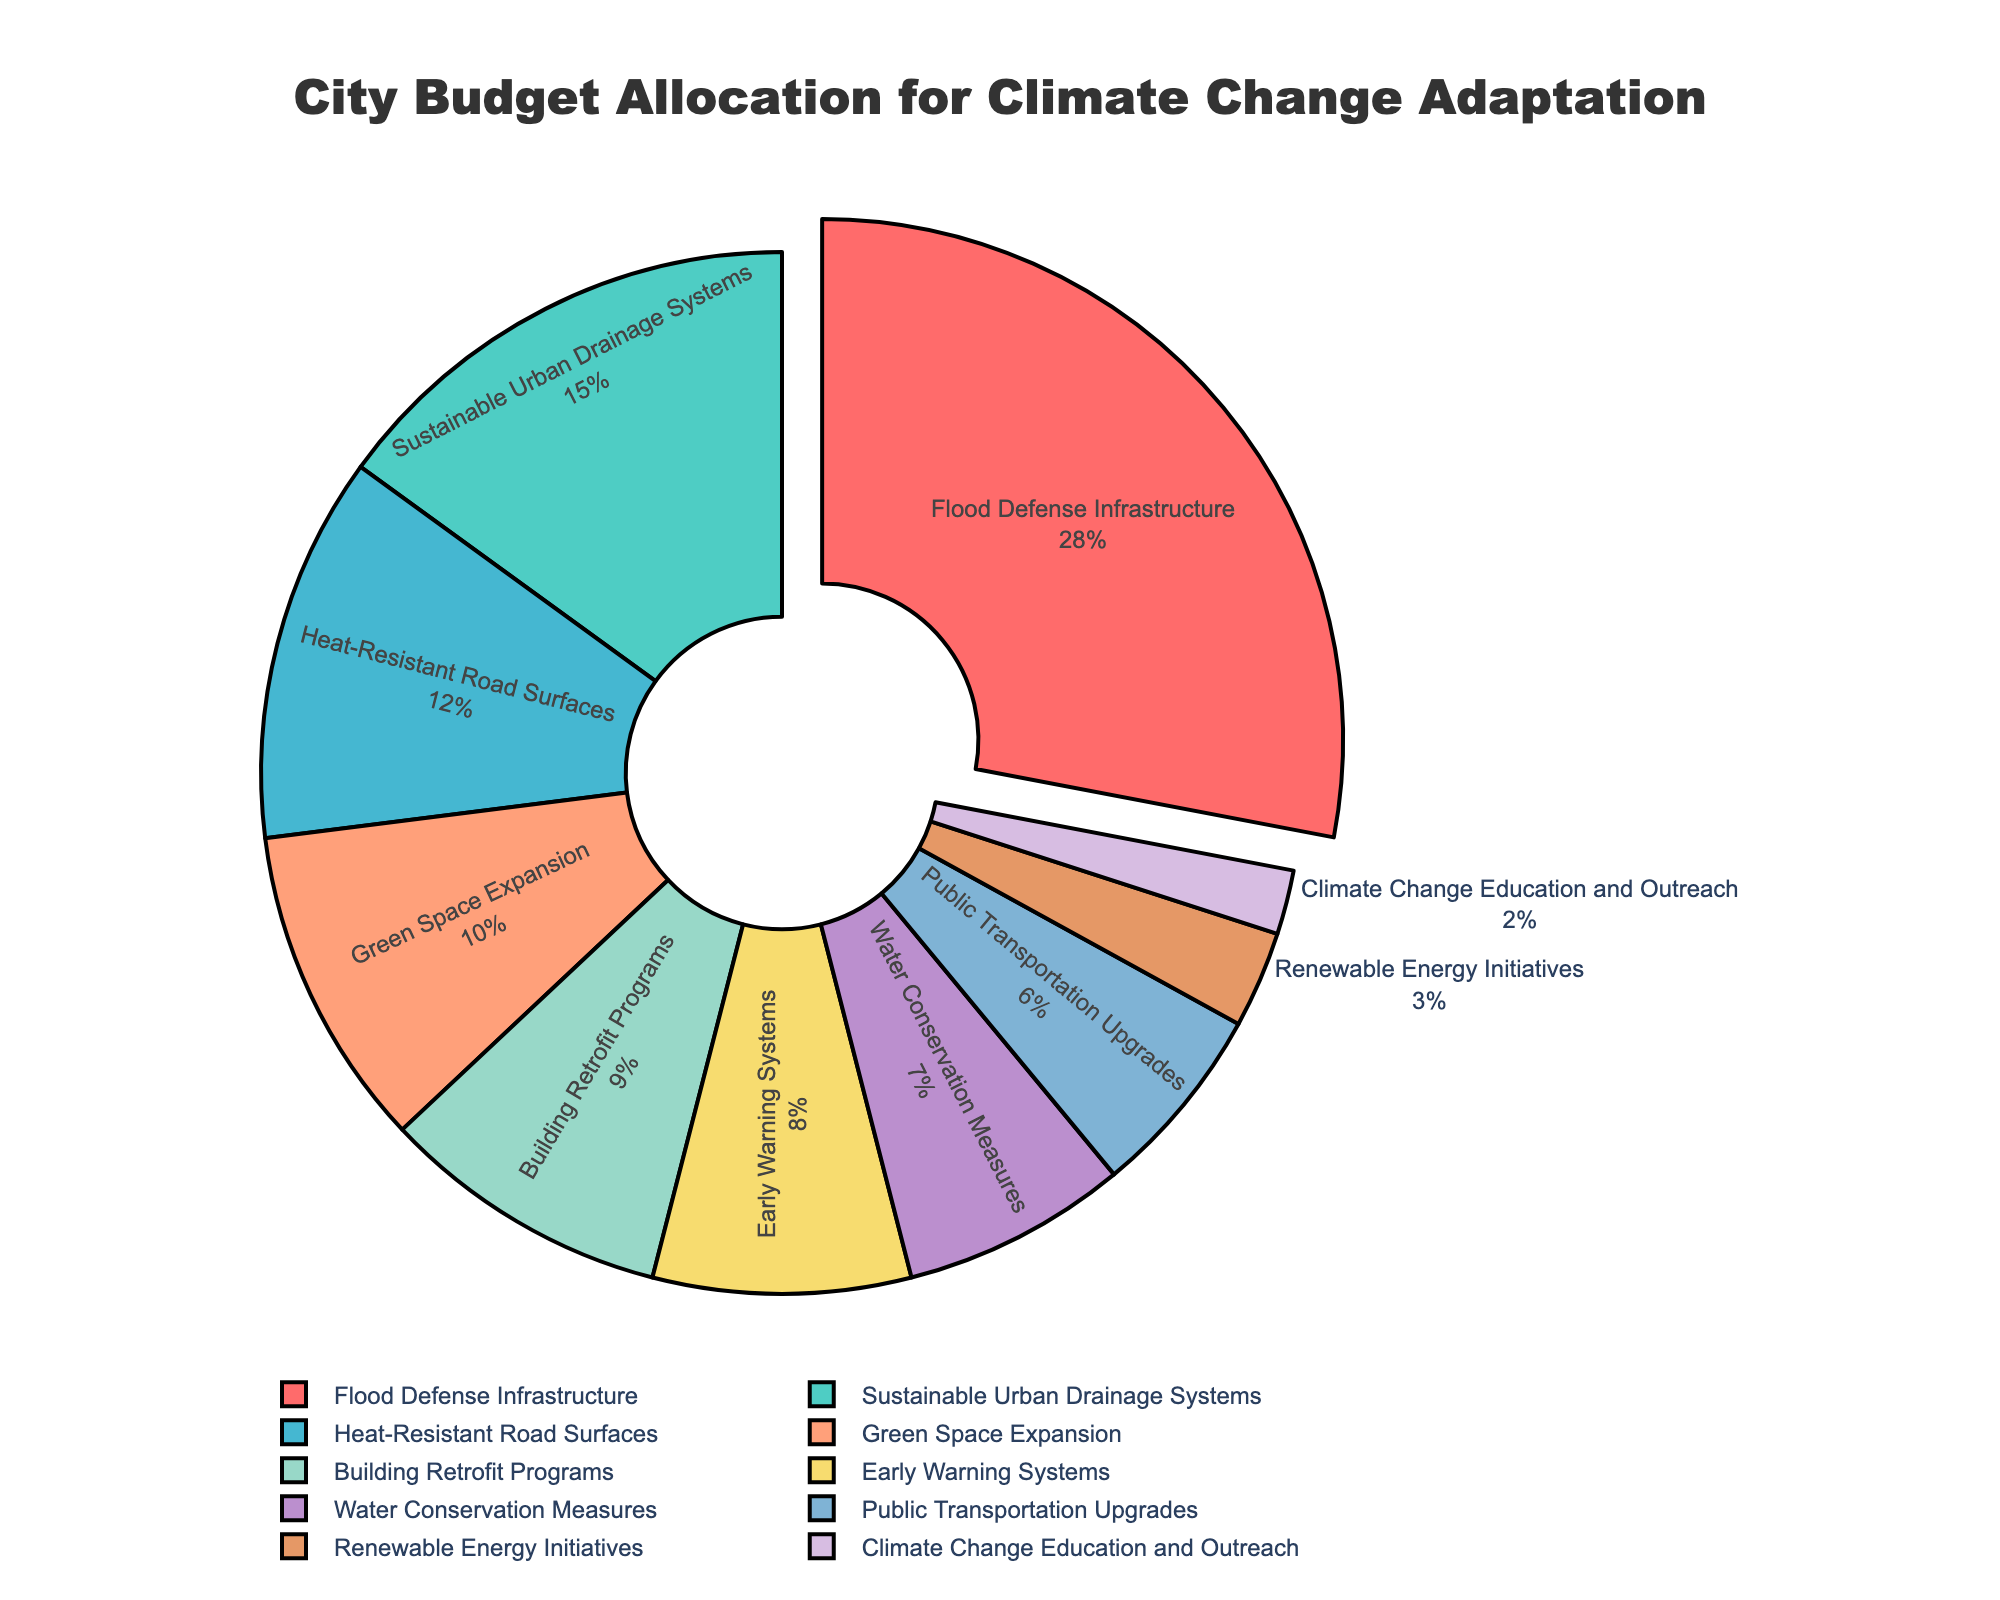What is the largest category in the city budget allocation for climate change adaptation? The largest budget allocation in the chart is visually represented by the largest pie slice, which is labeled "Flood Defense Infrastructure" with 28%.
Answer: Flood Defense Infrastructure How much more is allocated to Flood Defense Infrastructure than to Heat-Resistant Road Surfaces? Flood Defense Infrastructure is allocated 28%, and Heat-Resistant Road Surfaces is allocated 12%. The difference is calculated as 28% - 12%.
Answer: 16% What is the total percentage allocation for categories related to water management (Flood Defense Infrastructure, Sustainable Urban Drainage Systems, Water Conservation Measures)? The total is calculated by summing the percentages for Flood Defense Infrastructure (28%), Sustainable Urban Drainage Systems (15%), and Water Conservation Measures (7%). So, 28% + 15% + 7% = 50%.
Answer: 50% Which category has the smallest budget allocation and what is its percentage? The chart shows that Climate Change Education and Outreach has the smallest slice with a budget allocation labeled 2%.
Answer: Climate Change Education and Outreach at 2% How does the allocation for Green Space Expansion compare to that for Building Retrofit Programs? The pie chart shows Green Space Expansion at 10% and Building Retrofit Programs at 9%. Green Space Expansion has a slightly larger allocation.
Answer: Green Space Expansion is 1% more What percentage of the budget is allocated to infrastructure improvements (Flood Defense Infrastructure, Heat-Resistant Road Surfaces)? Add the percentages for Flood Defense Infrastructure (28%) and Heat-Resistant Road Surfaces (12%). So, 28% + 12% = 40%.
Answer: 40% Which categories are represented by colors green, red, and purple, and what are their respective percentages? Green represents Sustainable Urban Drainage Systems (15%), red represents Flood Defense Infrastructure (28%), and purple represents Building Retrofit Programs (9%).
Answer: Green - 15%, Red - 28%, Purple - 9% How do the budget allocations for Public Transportation Upgrades and Climate Change Education and Outreach combined compare to Early Warning Systems? Combine Public Transportation Upgrades (6%) and Climate Change Education and Outreach (2%) to get 6% + 2% = 8%. This is equal to the allocation for Early Warning Systems which is also 8%.
Answer: They are equal at 8% What percentage is allocated to Renewable Energy Initiatives and how does this compare to the allocation for Early Warning Systems? Renewable Energy Initiatives is allocated 3%, and Early Warning Systems is allocated 8%. We calculate the difference as 8% - 3% = 5%.
Answer: 5% less for Renewable Energy Initiatives What is the combined percentage allocation for categories that focus on environmental sustainability (Green Space Expansion, Water Conservation Measures, Renewable Energy Initiatives)? Combine Green Space Expansion (10%), Water Conservation Measures (7%), and Renewable Energy Initiatives (3%), which totals to 10% + 7% + 3% = 20%.
Answer: 20% 